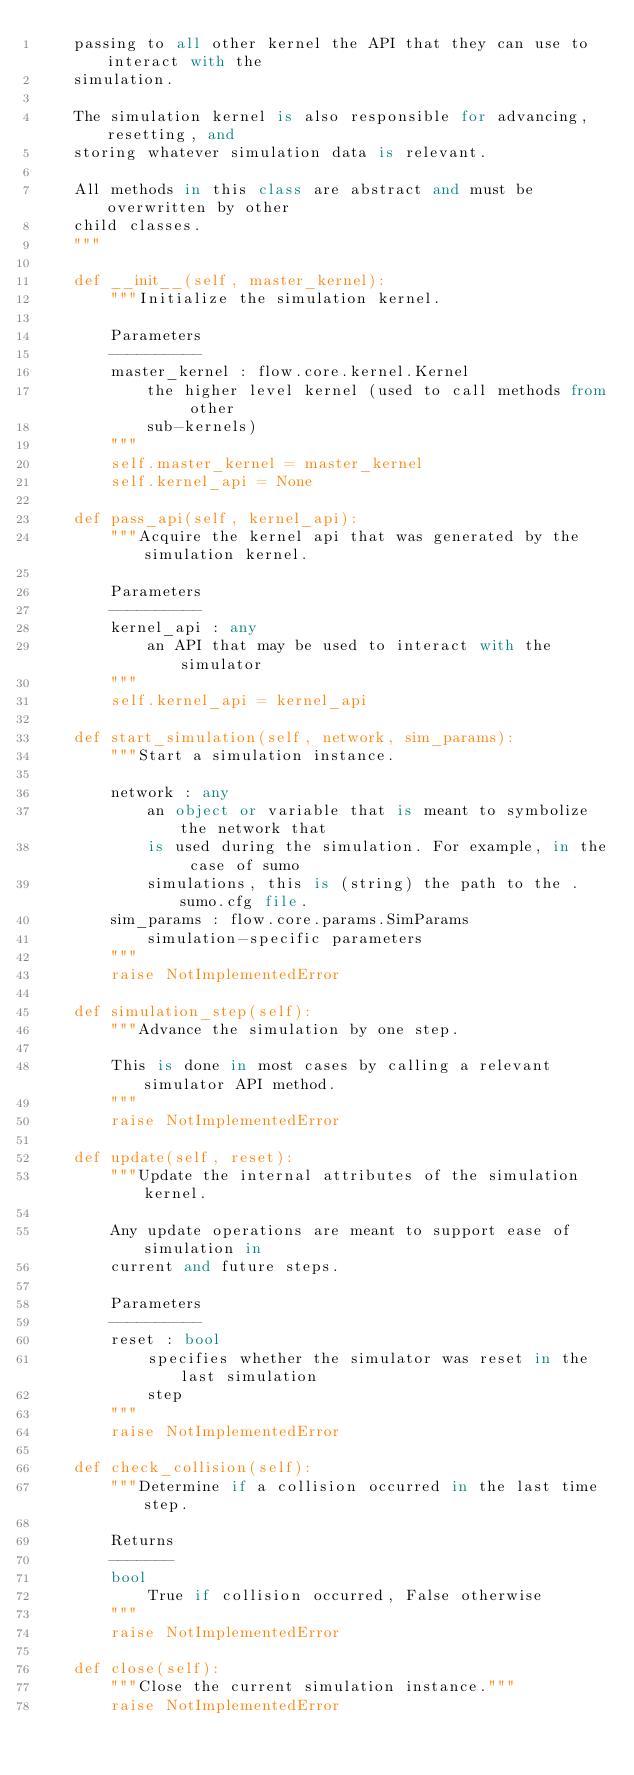Convert code to text. <code><loc_0><loc_0><loc_500><loc_500><_Python_>    passing to all other kernel the API that they can use to interact with the
    simulation.

    The simulation kernel is also responsible for advancing, resetting, and
    storing whatever simulation data is relevant.

    All methods in this class are abstract and must be overwritten by other
    child classes.
    """

    def __init__(self, master_kernel):
        """Initialize the simulation kernel.

        Parameters
        ----------
        master_kernel : flow.core.kernel.Kernel
            the higher level kernel (used to call methods from other
            sub-kernels)
        """
        self.master_kernel = master_kernel
        self.kernel_api = None

    def pass_api(self, kernel_api):
        """Acquire the kernel api that was generated by the simulation kernel.

        Parameters
        ----------
        kernel_api : any
            an API that may be used to interact with the simulator
        """
        self.kernel_api = kernel_api

    def start_simulation(self, network, sim_params):
        """Start a simulation instance.

        network : any
            an object or variable that is meant to symbolize the network that
            is used during the simulation. For example, in the case of sumo
            simulations, this is (string) the path to the .sumo.cfg file.
        sim_params : flow.core.params.SimParams
            simulation-specific parameters
        """
        raise NotImplementedError

    def simulation_step(self):
        """Advance the simulation by one step.

        This is done in most cases by calling a relevant simulator API method.
        """
        raise NotImplementedError

    def update(self, reset):
        """Update the internal attributes of the simulation kernel.

        Any update operations are meant to support ease of simulation in
        current and future steps.

        Parameters
        ----------
        reset : bool
            specifies whether the simulator was reset in the last simulation
            step
        """
        raise NotImplementedError

    def check_collision(self):
        """Determine if a collision occurred in the last time step.

        Returns
        -------
        bool
            True if collision occurred, False otherwise
        """
        raise NotImplementedError

    def close(self):
        """Close the current simulation instance."""
        raise NotImplementedError
</code> 